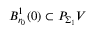<formula> <loc_0><loc_0><loc_500><loc_500>B _ { r _ { 0 } } ^ { 1 } ( 0 ) \subset P _ { \Sigma _ { 1 } } V</formula> 